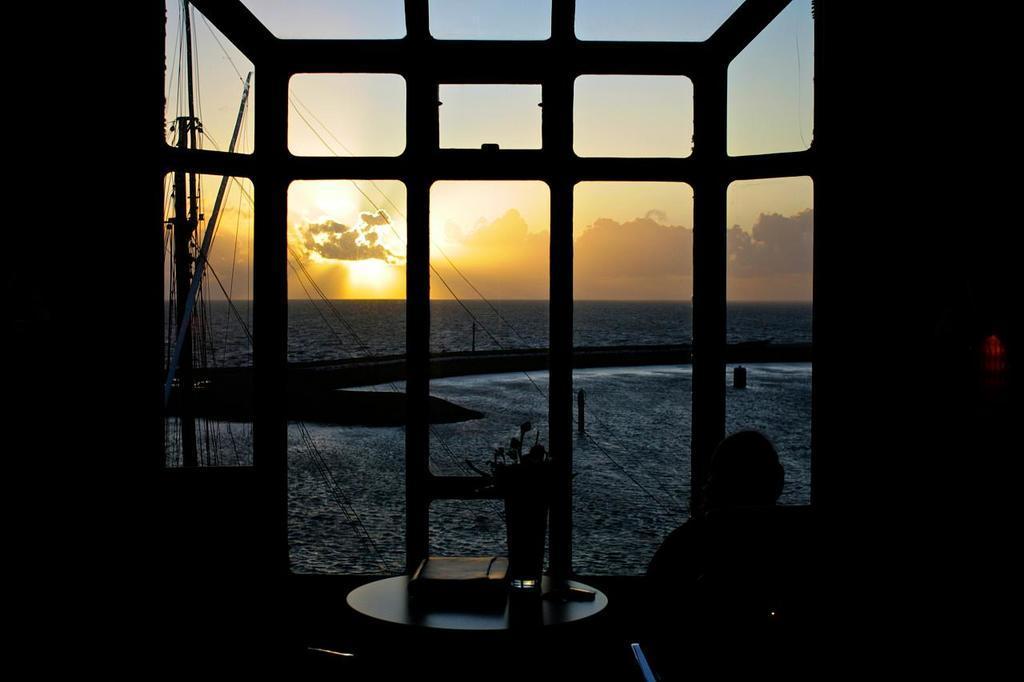Please provide a concise description of this image. Here in this picture in the front we can see a table with a book and a flower vase present on it over there and beside that we can see a person sitting on chair over there and in the front we can see a window through which we can see water present outside on the ground over there and we can see clouds in the sky and we can also see the sun present in the sky over there. 